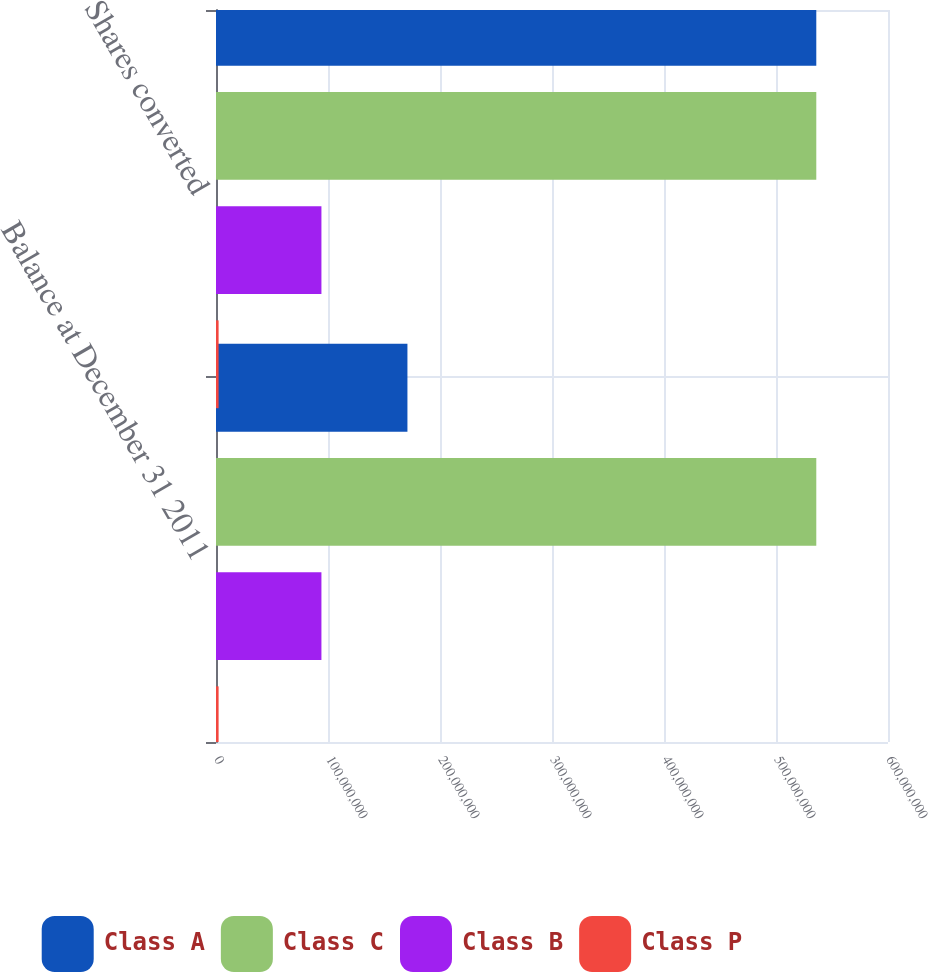<chart> <loc_0><loc_0><loc_500><loc_500><stacked_bar_chart><ecel><fcel>Balance at December 31 2011<fcel>Shares converted<nl><fcel>Class A<fcel>1.70921e+08<fcel>5.35972e+08<nl><fcel>Class C<fcel>5.35972e+08<fcel>5.35972e+08<nl><fcel>Class B<fcel>9.41326e+07<fcel>9.41326e+07<nl><fcel>Class P<fcel>2.31826e+06<fcel>2.31826e+06<nl></chart> 